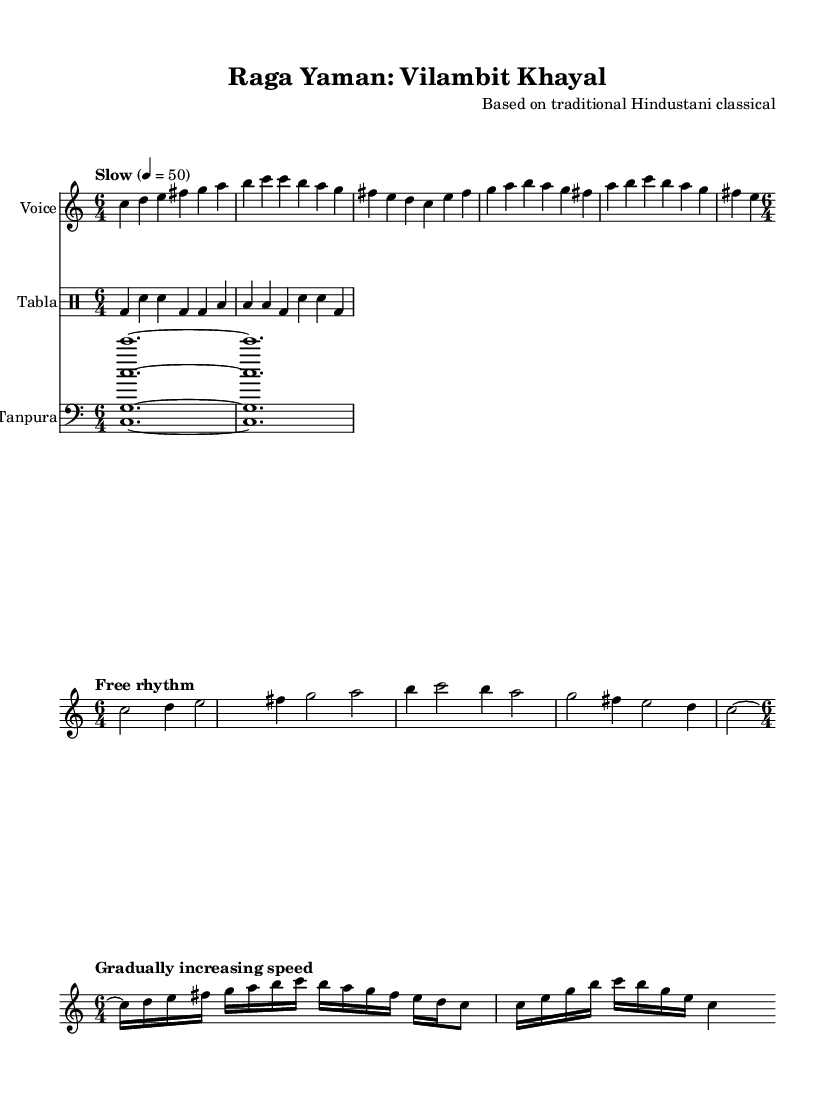What is the key signature of this music? The key signature indicated is C major, as shown at the beginning of the score with no sharp or flat symbols.
Answer: C major What is the time signature used in the main melody? The time signature for the main melody is 6/4, which is indicated at the start of the staff where the melody is written.
Answer: 6/4 What is the tempo marking for the main melody? The tempo marking for the main melody is "Slow" set at 50 beats per minute, as indicated near the beginning of the melody section.
Answer: Slow 4 = 50 How many measures are in the alap phrases section? By counting the lines in the alap phrases section, there are four measures, as each line represents two measures given the 6/4 time signature.
Answer: 4 What type of musical form is used in this performance? This performance employs a Khayal form, which is a traditional structure in Hindustani classical music, characterized by improvisation and elaboration of a raga.
Answer: Khayal What is the texture of the accompaniment in this piece? The accompaniment provided by the tabla and tanpura creates a drone texture, which is common in Hindustani classical music, offering a continuous harmonic support for the vocal line.
Answer: Drone What is the significance of the tanpura in this performance? The tanpura serves as a drone instrument, providing a sustained harmonic foundation that is essential for traditional Hindustani vocal performances, enriching the overall sound.
Answer: Harmonic foundation 